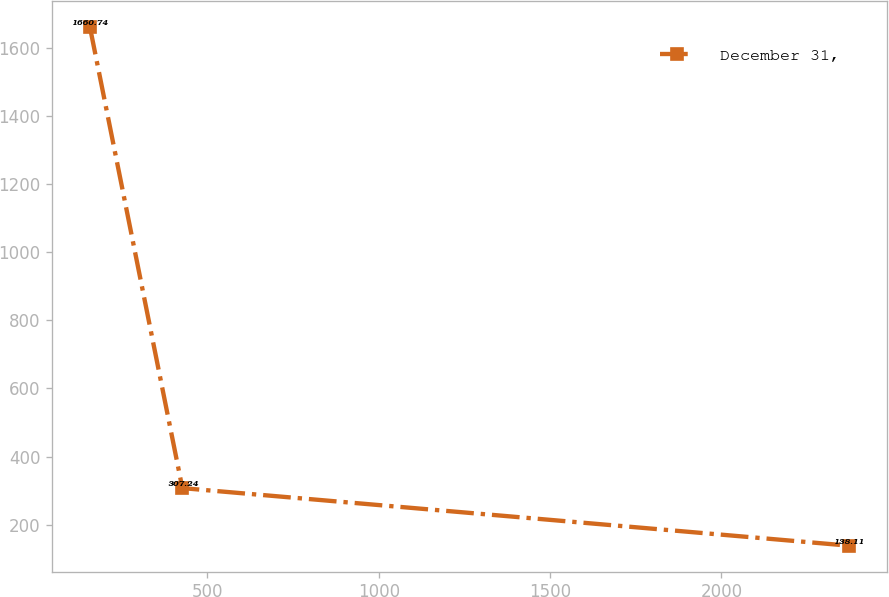<chart> <loc_0><loc_0><loc_500><loc_500><line_chart><ecel><fcel>December 31,<nl><fcel>157.16<fcel>1660.74<nl><fcel>426.83<fcel>307.24<nl><fcel>2372.39<fcel>138.11<nl></chart> 